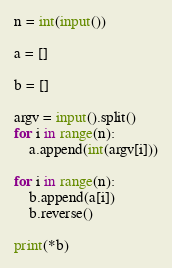Convert code to text. <code><loc_0><loc_0><loc_500><loc_500><_Python_>n = int(input())

a = []

b = []

argv = input().split()
for i in range(n):
    a.append(int(argv[i]))

for i in range(n):
    b.append(a[i])
    b.reverse()

print(*b)</code> 